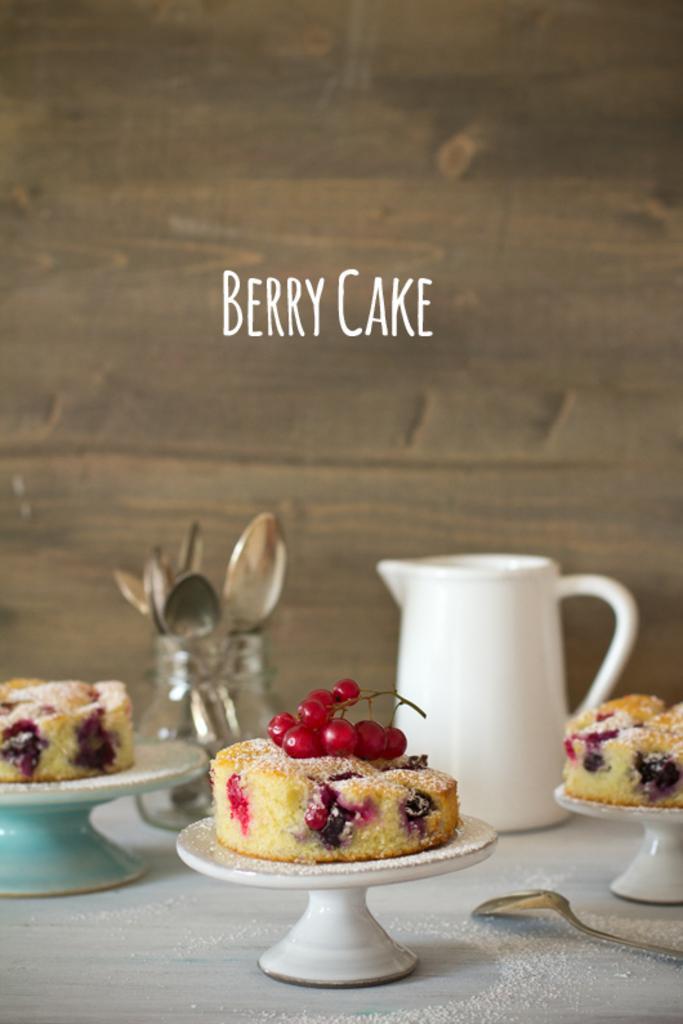Please provide a concise description of this image. In this image, we can see a table. On that table, we can see a stand with some cake. On the right side of the table, we can see a spoon. In the background of the table, we can see a jar and a glass jar, in the glass jar, we can see some spoons. In the background, we can see a wall. 